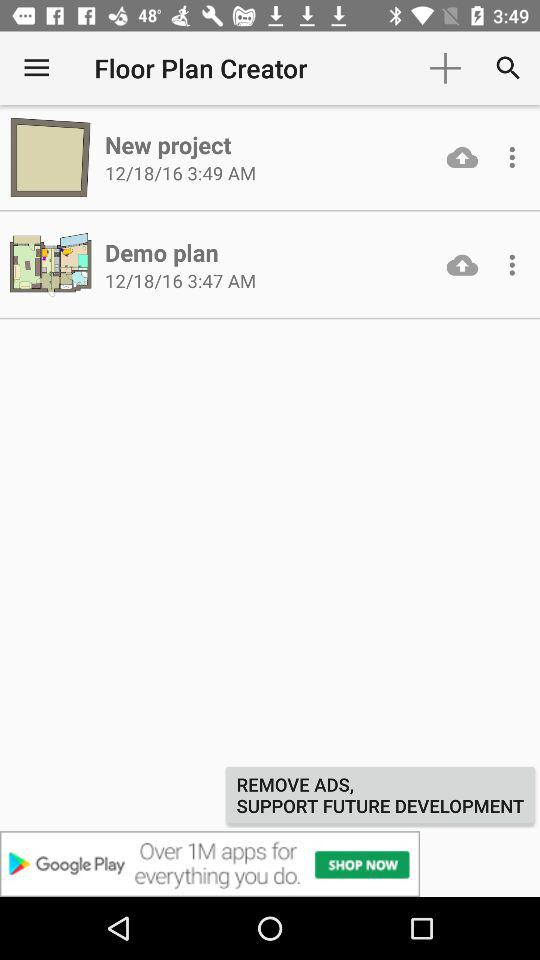When does the "New project" get created? The "New project" was created on December 18, 2016 at 3:49 AM. 